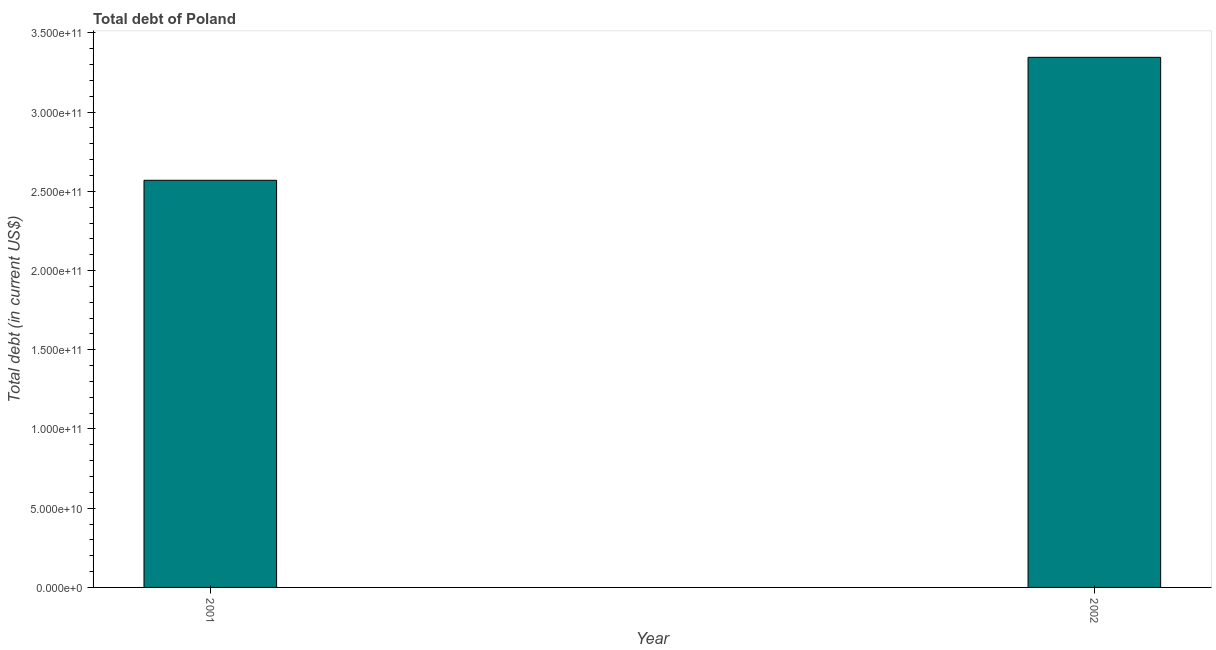Does the graph contain any zero values?
Your answer should be very brief. No. What is the title of the graph?
Keep it short and to the point. Total debt of Poland. What is the label or title of the X-axis?
Your answer should be very brief. Year. What is the label or title of the Y-axis?
Make the answer very short. Total debt (in current US$). What is the total debt in 2002?
Give a very brief answer. 3.35e+11. Across all years, what is the maximum total debt?
Provide a short and direct response. 3.35e+11. Across all years, what is the minimum total debt?
Provide a succinct answer. 2.57e+11. In which year was the total debt minimum?
Give a very brief answer. 2001. What is the sum of the total debt?
Provide a succinct answer. 5.92e+11. What is the difference between the total debt in 2001 and 2002?
Offer a terse response. -7.76e+1. What is the average total debt per year?
Your answer should be compact. 2.96e+11. What is the median total debt?
Keep it short and to the point. 2.96e+11. In how many years, is the total debt greater than 90000000000 US$?
Your answer should be compact. 2. Do a majority of the years between 2002 and 2001 (inclusive) have total debt greater than 230000000000 US$?
Provide a short and direct response. No. What is the ratio of the total debt in 2001 to that in 2002?
Offer a terse response. 0.77. How many years are there in the graph?
Your response must be concise. 2. Are the values on the major ticks of Y-axis written in scientific E-notation?
Offer a terse response. Yes. What is the Total debt (in current US$) in 2001?
Keep it short and to the point. 2.57e+11. What is the Total debt (in current US$) in 2002?
Offer a very short reply. 3.35e+11. What is the difference between the Total debt (in current US$) in 2001 and 2002?
Your response must be concise. -7.76e+1. What is the ratio of the Total debt (in current US$) in 2001 to that in 2002?
Ensure brevity in your answer.  0.77. 